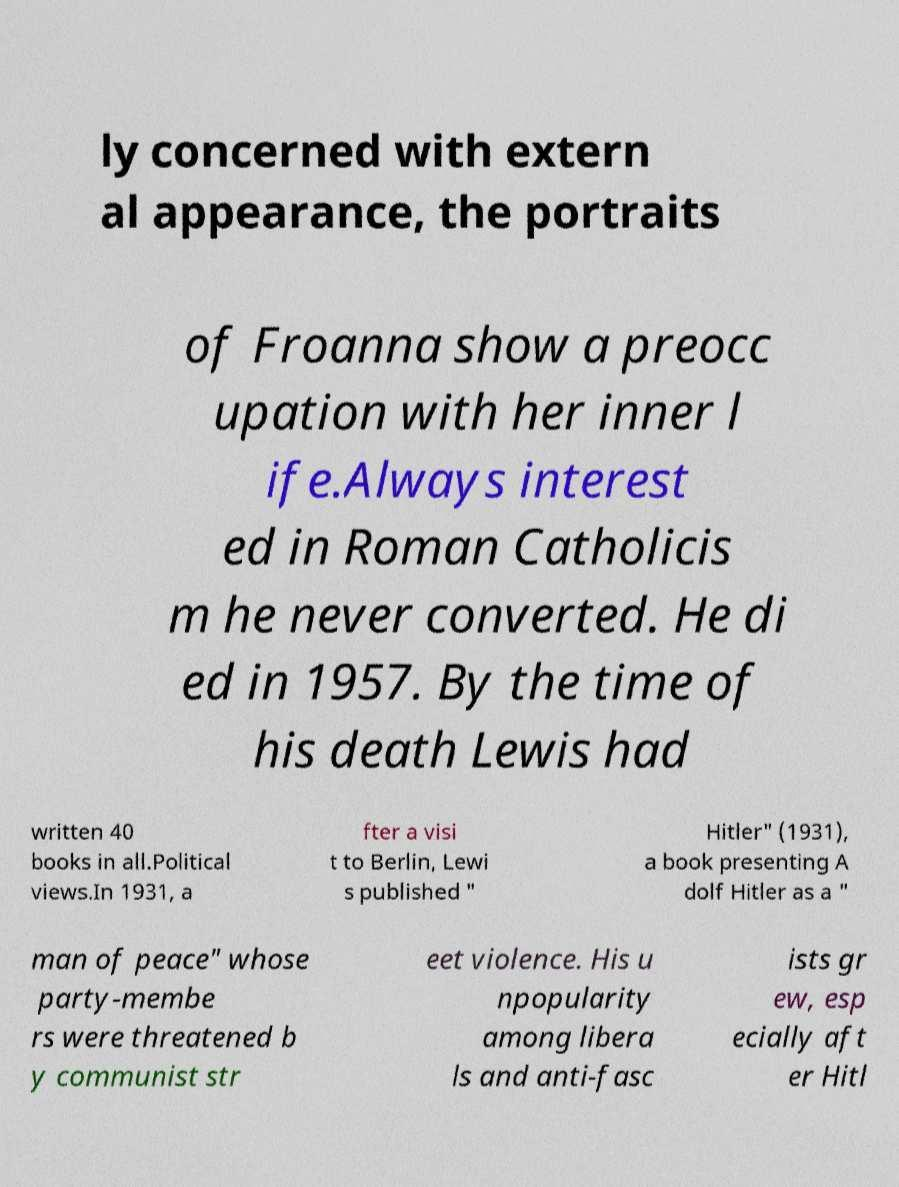Please identify and transcribe the text found in this image. ly concerned with extern al appearance, the portraits of Froanna show a preocc upation with her inner l ife.Always interest ed in Roman Catholicis m he never converted. He di ed in 1957. By the time of his death Lewis had written 40 books in all.Political views.In 1931, a fter a visi t to Berlin, Lewi s published " Hitler" (1931), a book presenting A dolf Hitler as a " man of peace" whose party-membe rs were threatened b y communist str eet violence. His u npopularity among libera ls and anti-fasc ists gr ew, esp ecially aft er Hitl 